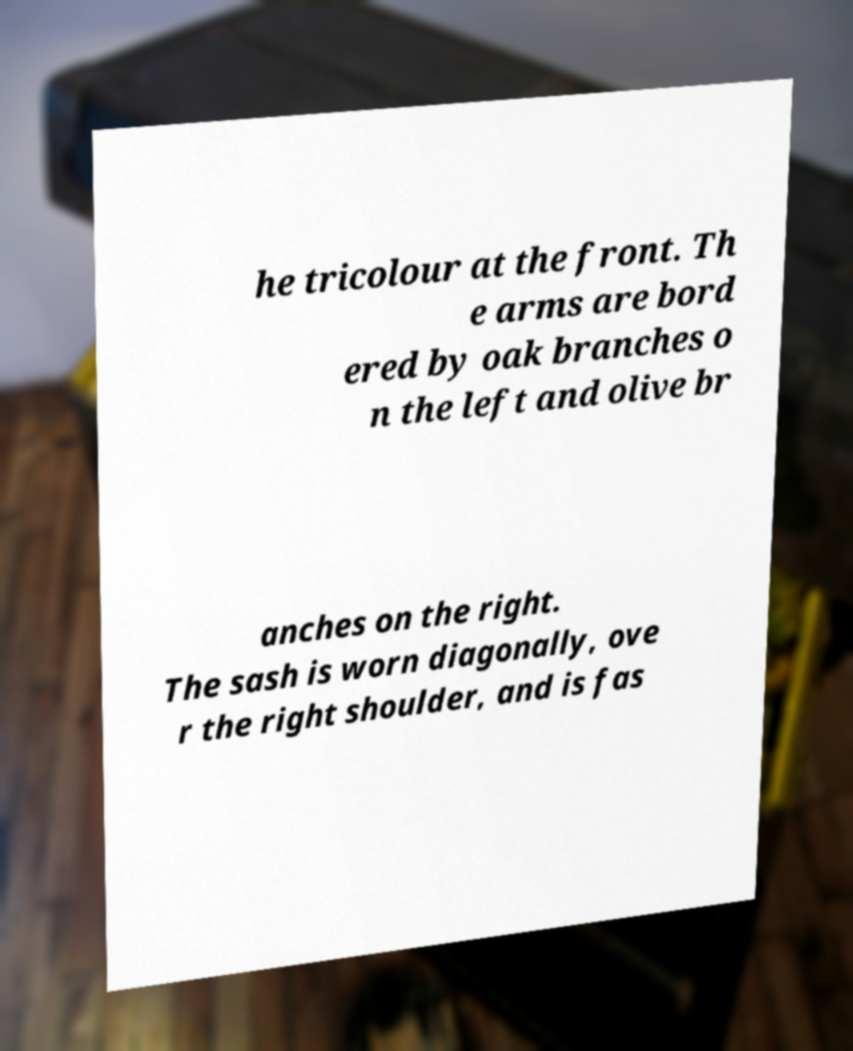What messages or text are displayed in this image? I need them in a readable, typed format. he tricolour at the front. Th e arms are bord ered by oak branches o n the left and olive br anches on the right. The sash is worn diagonally, ove r the right shoulder, and is fas 